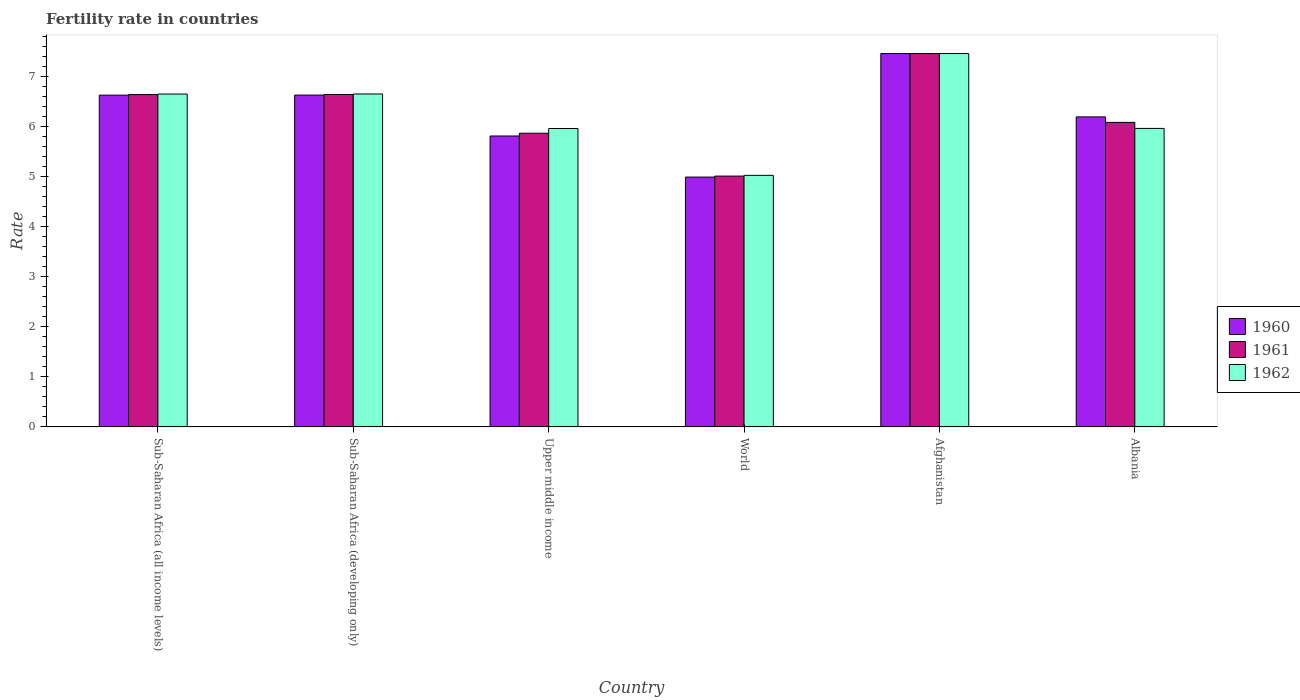Are the number of bars per tick equal to the number of legend labels?
Your response must be concise. Yes. Are the number of bars on each tick of the X-axis equal?
Offer a terse response. Yes. How many bars are there on the 4th tick from the left?
Make the answer very short. 3. What is the label of the 2nd group of bars from the left?
Give a very brief answer. Sub-Saharan Africa (developing only). In how many cases, is the number of bars for a given country not equal to the number of legend labels?
Your answer should be compact. 0. What is the fertility rate in 1961 in Upper middle income?
Provide a short and direct response. 5.86. Across all countries, what is the maximum fertility rate in 1962?
Give a very brief answer. 7.45. Across all countries, what is the minimum fertility rate in 1960?
Your answer should be compact. 4.99. In which country was the fertility rate in 1961 maximum?
Make the answer very short. Afghanistan. In which country was the fertility rate in 1960 minimum?
Your response must be concise. World. What is the total fertility rate in 1962 in the graph?
Offer a terse response. 37.66. What is the difference between the fertility rate in 1962 in Albania and that in Sub-Saharan Africa (developing only)?
Provide a short and direct response. -0.69. What is the difference between the fertility rate in 1961 in Afghanistan and the fertility rate in 1960 in Upper middle income?
Ensure brevity in your answer.  1.65. What is the average fertility rate in 1962 per country?
Offer a very short reply. 6.28. What is the difference between the fertility rate of/in 1962 and fertility rate of/in 1961 in Sub-Saharan Africa (all income levels)?
Your answer should be compact. 0.01. In how many countries, is the fertility rate in 1961 greater than 3.2?
Provide a short and direct response. 6. What is the ratio of the fertility rate in 1961 in Sub-Saharan Africa (all income levels) to that in Upper middle income?
Give a very brief answer. 1.13. Is the difference between the fertility rate in 1962 in Albania and Sub-Saharan Africa (developing only) greater than the difference between the fertility rate in 1961 in Albania and Sub-Saharan Africa (developing only)?
Your response must be concise. No. What is the difference between the highest and the second highest fertility rate in 1961?
Provide a succinct answer. -0. What is the difference between the highest and the lowest fertility rate in 1961?
Your answer should be very brief. 2.45. Is the sum of the fertility rate in 1962 in Sub-Saharan Africa (developing only) and Upper middle income greater than the maximum fertility rate in 1960 across all countries?
Give a very brief answer. Yes. What does the 1st bar from the left in Upper middle income represents?
Give a very brief answer. 1960. What does the 2nd bar from the right in Sub-Saharan Africa (all income levels) represents?
Provide a short and direct response. 1961. What is the difference between two consecutive major ticks on the Y-axis?
Provide a short and direct response. 1. Are the values on the major ticks of Y-axis written in scientific E-notation?
Provide a short and direct response. No. Does the graph contain any zero values?
Your response must be concise. No. Does the graph contain grids?
Keep it short and to the point. No. Where does the legend appear in the graph?
Keep it short and to the point. Center right. What is the title of the graph?
Ensure brevity in your answer.  Fertility rate in countries. What is the label or title of the Y-axis?
Your answer should be compact. Rate. What is the Rate in 1960 in Sub-Saharan Africa (all income levels)?
Offer a very short reply. 6.62. What is the Rate in 1961 in Sub-Saharan Africa (all income levels)?
Make the answer very short. 6.63. What is the Rate in 1962 in Sub-Saharan Africa (all income levels)?
Keep it short and to the point. 6.64. What is the Rate of 1960 in Sub-Saharan Africa (developing only)?
Your answer should be compact. 6.62. What is the Rate of 1961 in Sub-Saharan Africa (developing only)?
Provide a short and direct response. 6.63. What is the Rate of 1962 in Sub-Saharan Africa (developing only)?
Keep it short and to the point. 6.64. What is the Rate in 1960 in Upper middle income?
Ensure brevity in your answer.  5.8. What is the Rate in 1961 in Upper middle income?
Ensure brevity in your answer.  5.86. What is the Rate in 1962 in Upper middle income?
Ensure brevity in your answer.  5.95. What is the Rate of 1960 in World?
Give a very brief answer. 4.99. What is the Rate in 1961 in World?
Make the answer very short. 5. What is the Rate in 1962 in World?
Offer a terse response. 5.02. What is the Rate of 1960 in Afghanistan?
Your answer should be compact. 7.45. What is the Rate in 1961 in Afghanistan?
Keep it short and to the point. 7.45. What is the Rate in 1962 in Afghanistan?
Provide a short and direct response. 7.45. What is the Rate in 1960 in Albania?
Offer a terse response. 6.19. What is the Rate of 1961 in Albania?
Your answer should be compact. 6.08. What is the Rate of 1962 in Albania?
Provide a short and direct response. 5.96. Across all countries, what is the maximum Rate in 1960?
Provide a short and direct response. 7.45. Across all countries, what is the maximum Rate of 1961?
Your answer should be compact. 7.45. Across all countries, what is the maximum Rate of 1962?
Ensure brevity in your answer.  7.45. Across all countries, what is the minimum Rate in 1960?
Your answer should be compact. 4.99. Across all countries, what is the minimum Rate of 1961?
Offer a very short reply. 5. Across all countries, what is the minimum Rate of 1962?
Keep it short and to the point. 5.02. What is the total Rate in 1960 in the graph?
Provide a short and direct response. 37.67. What is the total Rate of 1961 in the graph?
Make the answer very short. 37.65. What is the total Rate of 1962 in the graph?
Provide a succinct answer. 37.66. What is the difference between the Rate of 1960 in Sub-Saharan Africa (all income levels) and that in Sub-Saharan Africa (developing only)?
Keep it short and to the point. -0. What is the difference between the Rate of 1961 in Sub-Saharan Africa (all income levels) and that in Sub-Saharan Africa (developing only)?
Your answer should be very brief. -0. What is the difference between the Rate of 1962 in Sub-Saharan Africa (all income levels) and that in Sub-Saharan Africa (developing only)?
Offer a very short reply. -0. What is the difference between the Rate in 1960 in Sub-Saharan Africa (all income levels) and that in Upper middle income?
Offer a terse response. 0.82. What is the difference between the Rate of 1961 in Sub-Saharan Africa (all income levels) and that in Upper middle income?
Make the answer very short. 0.77. What is the difference between the Rate in 1962 in Sub-Saharan Africa (all income levels) and that in Upper middle income?
Give a very brief answer. 0.69. What is the difference between the Rate of 1960 in Sub-Saharan Africa (all income levels) and that in World?
Make the answer very short. 1.64. What is the difference between the Rate of 1961 in Sub-Saharan Africa (all income levels) and that in World?
Keep it short and to the point. 1.63. What is the difference between the Rate in 1962 in Sub-Saharan Africa (all income levels) and that in World?
Ensure brevity in your answer.  1.62. What is the difference between the Rate in 1960 in Sub-Saharan Africa (all income levels) and that in Afghanistan?
Offer a terse response. -0.83. What is the difference between the Rate of 1961 in Sub-Saharan Africa (all income levels) and that in Afghanistan?
Your response must be concise. -0.82. What is the difference between the Rate of 1962 in Sub-Saharan Africa (all income levels) and that in Afghanistan?
Provide a succinct answer. -0.81. What is the difference between the Rate of 1960 in Sub-Saharan Africa (all income levels) and that in Albania?
Give a very brief answer. 0.43. What is the difference between the Rate in 1961 in Sub-Saharan Africa (all income levels) and that in Albania?
Offer a terse response. 0.56. What is the difference between the Rate in 1962 in Sub-Saharan Africa (all income levels) and that in Albania?
Keep it short and to the point. 0.69. What is the difference between the Rate of 1960 in Sub-Saharan Africa (developing only) and that in Upper middle income?
Give a very brief answer. 0.82. What is the difference between the Rate of 1961 in Sub-Saharan Africa (developing only) and that in Upper middle income?
Ensure brevity in your answer.  0.77. What is the difference between the Rate of 1962 in Sub-Saharan Africa (developing only) and that in Upper middle income?
Keep it short and to the point. 0.69. What is the difference between the Rate of 1960 in Sub-Saharan Africa (developing only) and that in World?
Provide a succinct answer. 1.64. What is the difference between the Rate in 1961 in Sub-Saharan Africa (developing only) and that in World?
Offer a very short reply. 1.63. What is the difference between the Rate in 1962 in Sub-Saharan Africa (developing only) and that in World?
Your answer should be very brief. 1.62. What is the difference between the Rate in 1960 in Sub-Saharan Africa (developing only) and that in Afghanistan?
Give a very brief answer. -0.83. What is the difference between the Rate in 1961 in Sub-Saharan Africa (developing only) and that in Afghanistan?
Ensure brevity in your answer.  -0.82. What is the difference between the Rate of 1962 in Sub-Saharan Africa (developing only) and that in Afghanistan?
Your answer should be very brief. -0.81. What is the difference between the Rate in 1960 in Sub-Saharan Africa (developing only) and that in Albania?
Make the answer very short. 0.44. What is the difference between the Rate in 1961 in Sub-Saharan Africa (developing only) and that in Albania?
Ensure brevity in your answer.  0.56. What is the difference between the Rate in 1962 in Sub-Saharan Africa (developing only) and that in Albania?
Your answer should be compact. 0.69. What is the difference between the Rate in 1960 in Upper middle income and that in World?
Keep it short and to the point. 0.82. What is the difference between the Rate in 1961 in Upper middle income and that in World?
Provide a succinct answer. 0.86. What is the difference between the Rate in 1962 in Upper middle income and that in World?
Keep it short and to the point. 0.93. What is the difference between the Rate of 1960 in Upper middle income and that in Afghanistan?
Provide a short and direct response. -1.65. What is the difference between the Rate in 1961 in Upper middle income and that in Afghanistan?
Provide a short and direct response. -1.59. What is the difference between the Rate in 1962 in Upper middle income and that in Afghanistan?
Your answer should be very brief. -1.5. What is the difference between the Rate in 1960 in Upper middle income and that in Albania?
Ensure brevity in your answer.  -0.38. What is the difference between the Rate in 1961 in Upper middle income and that in Albania?
Your response must be concise. -0.22. What is the difference between the Rate of 1962 in Upper middle income and that in Albania?
Your response must be concise. -0. What is the difference between the Rate of 1960 in World and that in Afghanistan?
Provide a succinct answer. -2.46. What is the difference between the Rate of 1961 in World and that in Afghanistan?
Make the answer very short. -2.45. What is the difference between the Rate in 1962 in World and that in Afghanistan?
Offer a very short reply. -2.43. What is the difference between the Rate of 1960 in World and that in Albania?
Provide a short and direct response. -1.2. What is the difference between the Rate of 1961 in World and that in Albania?
Give a very brief answer. -1.07. What is the difference between the Rate in 1962 in World and that in Albania?
Make the answer very short. -0.94. What is the difference between the Rate in 1960 in Afghanistan and that in Albania?
Your response must be concise. 1.26. What is the difference between the Rate in 1961 in Afghanistan and that in Albania?
Offer a very short reply. 1.37. What is the difference between the Rate of 1962 in Afghanistan and that in Albania?
Offer a very short reply. 1.49. What is the difference between the Rate of 1960 in Sub-Saharan Africa (all income levels) and the Rate of 1961 in Sub-Saharan Africa (developing only)?
Ensure brevity in your answer.  -0.01. What is the difference between the Rate in 1960 in Sub-Saharan Africa (all income levels) and the Rate in 1962 in Sub-Saharan Africa (developing only)?
Your answer should be compact. -0.02. What is the difference between the Rate in 1961 in Sub-Saharan Africa (all income levels) and the Rate in 1962 in Sub-Saharan Africa (developing only)?
Your response must be concise. -0.01. What is the difference between the Rate of 1960 in Sub-Saharan Africa (all income levels) and the Rate of 1961 in Upper middle income?
Your answer should be very brief. 0.76. What is the difference between the Rate in 1960 in Sub-Saharan Africa (all income levels) and the Rate in 1962 in Upper middle income?
Keep it short and to the point. 0.67. What is the difference between the Rate of 1961 in Sub-Saharan Africa (all income levels) and the Rate of 1962 in Upper middle income?
Keep it short and to the point. 0.68. What is the difference between the Rate in 1960 in Sub-Saharan Africa (all income levels) and the Rate in 1961 in World?
Ensure brevity in your answer.  1.62. What is the difference between the Rate in 1960 in Sub-Saharan Africa (all income levels) and the Rate in 1962 in World?
Provide a short and direct response. 1.6. What is the difference between the Rate of 1961 in Sub-Saharan Africa (all income levels) and the Rate of 1962 in World?
Make the answer very short. 1.61. What is the difference between the Rate of 1960 in Sub-Saharan Africa (all income levels) and the Rate of 1961 in Afghanistan?
Make the answer very short. -0.83. What is the difference between the Rate of 1960 in Sub-Saharan Africa (all income levels) and the Rate of 1962 in Afghanistan?
Keep it short and to the point. -0.83. What is the difference between the Rate in 1961 in Sub-Saharan Africa (all income levels) and the Rate in 1962 in Afghanistan?
Provide a succinct answer. -0.82. What is the difference between the Rate of 1960 in Sub-Saharan Africa (all income levels) and the Rate of 1961 in Albania?
Make the answer very short. 0.54. What is the difference between the Rate of 1960 in Sub-Saharan Africa (all income levels) and the Rate of 1962 in Albania?
Give a very brief answer. 0.66. What is the difference between the Rate of 1961 in Sub-Saharan Africa (all income levels) and the Rate of 1962 in Albania?
Your answer should be very brief. 0.68. What is the difference between the Rate in 1960 in Sub-Saharan Africa (developing only) and the Rate in 1961 in Upper middle income?
Your answer should be compact. 0.76. What is the difference between the Rate of 1960 in Sub-Saharan Africa (developing only) and the Rate of 1962 in Upper middle income?
Provide a short and direct response. 0.67. What is the difference between the Rate of 1961 in Sub-Saharan Africa (developing only) and the Rate of 1962 in Upper middle income?
Provide a succinct answer. 0.68. What is the difference between the Rate of 1960 in Sub-Saharan Africa (developing only) and the Rate of 1961 in World?
Your answer should be compact. 1.62. What is the difference between the Rate of 1960 in Sub-Saharan Africa (developing only) and the Rate of 1962 in World?
Make the answer very short. 1.6. What is the difference between the Rate of 1961 in Sub-Saharan Africa (developing only) and the Rate of 1962 in World?
Offer a terse response. 1.61. What is the difference between the Rate of 1960 in Sub-Saharan Africa (developing only) and the Rate of 1961 in Afghanistan?
Offer a terse response. -0.83. What is the difference between the Rate of 1960 in Sub-Saharan Africa (developing only) and the Rate of 1962 in Afghanistan?
Ensure brevity in your answer.  -0.83. What is the difference between the Rate of 1961 in Sub-Saharan Africa (developing only) and the Rate of 1962 in Afghanistan?
Your answer should be compact. -0.82. What is the difference between the Rate of 1960 in Sub-Saharan Africa (developing only) and the Rate of 1961 in Albania?
Your answer should be compact. 0.55. What is the difference between the Rate in 1960 in Sub-Saharan Africa (developing only) and the Rate in 1962 in Albania?
Ensure brevity in your answer.  0.67. What is the difference between the Rate in 1961 in Sub-Saharan Africa (developing only) and the Rate in 1962 in Albania?
Your answer should be very brief. 0.68. What is the difference between the Rate in 1960 in Upper middle income and the Rate in 1962 in World?
Make the answer very short. 0.79. What is the difference between the Rate in 1961 in Upper middle income and the Rate in 1962 in World?
Ensure brevity in your answer.  0.84. What is the difference between the Rate of 1960 in Upper middle income and the Rate of 1961 in Afghanistan?
Offer a very short reply. -1.65. What is the difference between the Rate in 1960 in Upper middle income and the Rate in 1962 in Afghanistan?
Provide a short and direct response. -1.65. What is the difference between the Rate of 1961 in Upper middle income and the Rate of 1962 in Afghanistan?
Your answer should be very brief. -1.59. What is the difference between the Rate in 1960 in Upper middle income and the Rate in 1961 in Albania?
Provide a short and direct response. -0.27. What is the difference between the Rate in 1960 in Upper middle income and the Rate in 1962 in Albania?
Ensure brevity in your answer.  -0.15. What is the difference between the Rate of 1961 in Upper middle income and the Rate of 1962 in Albania?
Ensure brevity in your answer.  -0.1. What is the difference between the Rate in 1960 in World and the Rate in 1961 in Afghanistan?
Ensure brevity in your answer.  -2.46. What is the difference between the Rate of 1960 in World and the Rate of 1962 in Afghanistan?
Provide a short and direct response. -2.46. What is the difference between the Rate of 1961 in World and the Rate of 1962 in Afghanistan?
Ensure brevity in your answer.  -2.45. What is the difference between the Rate of 1960 in World and the Rate of 1961 in Albania?
Provide a succinct answer. -1.09. What is the difference between the Rate of 1960 in World and the Rate of 1962 in Albania?
Your answer should be very brief. -0.97. What is the difference between the Rate in 1961 in World and the Rate in 1962 in Albania?
Give a very brief answer. -0.95. What is the difference between the Rate of 1960 in Afghanistan and the Rate of 1961 in Albania?
Your response must be concise. 1.37. What is the difference between the Rate of 1960 in Afghanistan and the Rate of 1962 in Albania?
Provide a short and direct response. 1.49. What is the difference between the Rate in 1961 in Afghanistan and the Rate in 1962 in Albania?
Your response must be concise. 1.49. What is the average Rate in 1960 per country?
Give a very brief answer. 6.28. What is the average Rate of 1961 per country?
Your response must be concise. 6.28. What is the average Rate of 1962 per country?
Provide a succinct answer. 6.28. What is the difference between the Rate in 1960 and Rate in 1961 in Sub-Saharan Africa (all income levels)?
Offer a terse response. -0.01. What is the difference between the Rate of 1960 and Rate of 1962 in Sub-Saharan Africa (all income levels)?
Give a very brief answer. -0.02. What is the difference between the Rate of 1961 and Rate of 1962 in Sub-Saharan Africa (all income levels)?
Your answer should be very brief. -0.01. What is the difference between the Rate of 1960 and Rate of 1961 in Sub-Saharan Africa (developing only)?
Your response must be concise. -0.01. What is the difference between the Rate in 1960 and Rate in 1962 in Sub-Saharan Africa (developing only)?
Make the answer very short. -0.02. What is the difference between the Rate of 1961 and Rate of 1962 in Sub-Saharan Africa (developing only)?
Offer a very short reply. -0.01. What is the difference between the Rate of 1960 and Rate of 1961 in Upper middle income?
Provide a short and direct response. -0.06. What is the difference between the Rate in 1960 and Rate in 1962 in Upper middle income?
Give a very brief answer. -0.15. What is the difference between the Rate in 1961 and Rate in 1962 in Upper middle income?
Your answer should be very brief. -0.09. What is the difference between the Rate in 1960 and Rate in 1961 in World?
Your answer should be very brief. -0.02. What is the difference between the Rate in 1960 and Rate in 1962 in World?
Your answer should be very brief. -0.03. What is the difference between the Rate of 1961 and Rate of 1962 in World?
Your answer should be very brief. -0.01. What is the difference between the Rate of 1961 and Rate of 1962 in Afghanistan?
Keep it short and to the point. 0. What is the difference between the Rate of 1960 and Rate of 1961 in Albania?
Keep it short and to the point. 0.11. What is the difference between the Rate in 1960 and Rate in 1962 in Albania?
Make the answer very short. 0.23. What is the difference between the Rate of 1961 and Rate of 1962 in Albania?
Ensure brevity in your answer.  0.12. What is the ratio of the Rate in 1960 in Sub-Saharan Africa (all income levels) to that in Sub-Saharan Africa (developing only)?
Provide a short and direct response. 1. What is the ratio of the Rate in 1962 in Sub-Saharan Africa (all income levels) to that in Sub-Saharan Africa (developing only)?
Offer a very short reply. 1. What is the ratio of the Rate of 1960 in Sub-Saharan Africa (all income levels) to that in Upper middle income?
Offer a terse response. 1.14. What is the ratio of the Rate in 1961 in Sub-Saharan Africa (all income levels) to that in Upper middle income?
Offer a very short reply. 1.13. What is the ratio of the Rate in 1962 in Sub-Saharan Africa (all income levels) to that in Upper middle income?
Provide a short and direct response. 1.12. What is the ratio of the Rate in 1960 in Sub-Saharan Africa (all income levels) to that in World?
Your response must be concise. 1.33. What is the ratio of the Rate in 1961 in Sub-Saharan Africa (all income levels) to that in World?
Provide a succinct answer. 1.33. What is the ratio of the Rate of 1962 in Sub-Saharan Africa (all income levels) to that in World?
Your answer should be very brief. 1.32. What is the ratio of the Rate in 1960 in Sub-Saharan Africa (all income levels) to that in Afghanistan?
Provide a succinct answer. 0.89. What is the ratio of the Rate of 1961 in Sub-Saharan Africa (all income levels) to that in Afghanistan?
Provide a short and direct response. 0.89. What is the ratio of the Rate of 1962 in Sub-Saharan Africa (all income levels) to that in Afghanistan?
Ensure brevity in your answer.  0.89. What is the ratio of the Rate in 1960 in Sub-Saharan Africa (all income levels) to that in Albania?
Your response must be concise. 1.07. What is the ratio of the Rate in 1961 in Sub-Saharan Africa (all income levels) to that in Albania?
Keep it short and to the point. 1.09. What is the ratio of the Rate in 1962 in Sub-Saharan Africa (all income levels) to that in Albania?
Offer a very short reply. 1.12. What is the ratio of the Rate of 1960 in Sub-Saharan Africa (developing only) to that in Upper middle income?
Make the answer very short. 1.14. What is the ratio of the Rate of 1961 in Sub-Saharan Africa (developing only) to that in Upper middle income?
Your response must be concise. 1.13. What is the ratio of the Rate of 1962 in Sub-Saharan Africa (developing only) to that in Upper middle income?
Offer a terse response. 1.12. What is the ratio of the Rate in 1960 in Sub-Saharan Africa (developing only) to that in World?
Your response must be concise. 1.33. What is the ratio of the Rate of 1961 in Sub-Saharan Africa (developing only) to that in World?
Provide a succinct answer. 1.33. What is the ratio of the Rate in 1962 in Sub-Saharan Africa (developing only) to that in World?
Offer a terse response. 1.32. What is the ratio of the Rate in 1960 in Sub-Saharan Africa (developing only) to that in Afghanistan?
Offer a terse response. 0.89. What is the ratio of the Rate in 1961 in Sub-Saharan Africa (developing only) to that in Afghanistan?
Keep it short and to the point. 0.89. What is the ratio of the Rate in 1962 in Sub-Saharan Africa (developing only) to that in Afghanistan?
Give a very brief answer. 0.89. What is the ratio of the Rate in 1960 in Sub-Saharan Africa (developing only) to that in Albania?
Offer a terse response. 1.07. What is the ratio of the Rate of 1961 in Sub-Saharan Africa (developing only) to that in Albania?
Ensure brevity in your answer.  1.09. What is the ratio of the Rate of 1962 in Sub-Saharan Africa (developing only) to that in Albania?
Provide a succinct answer. 1.12. What is the ratio of the Rate in 1960 in Upper middle income to that in World?
Make the answer very short. 1.16. What is the ratio of the Rate in 1961 in Upper middle income to that in World?
Provide a succinct answer. 1.17. What is the ratio of the Rate of 1962 in Upper middle income to that in World?
Ensure brevity in your answer.  1.19. What is the ratio of the Rate of 1960 in Upper middle income to that in Afghanistan?
Give a very brief answer. 0.78. What is the ratio of the Rate of 1961 in Upper middle income to that in Afghanistan?
Provide a short and direct response. 0.79. What is the ratio of the Rate of 1962 in Upper middle income to that in Afghanistan?
Your response must be concise. 0.8. What is the ratio of the Rate of 1960 in Upper middle income to that in Albania?
Your response must be concise. 0.94. What is the ratio of the Rate in 1961 in Upper middle income to that in Albania?
Ensure brevity in your answer.  0.96. What is the ratio of the Rate of 1960 in World to that in Afghanistan?
Your answer should be very brief. 0.67. What is the ratio of the Rate in 1961 in World to that in Afghanistan?
Offer a terse response. 0.67. What is the ratio of the Rate of 1962 in World to that in Afghanistan?
Make the answer very short. 0.67. What is the ratio of the Rate of 1960 in World to that in Albania?
Provide a short and direct response. 0.81. What is the ratio of the Rate of 1961 in World to that in Albania?
Offer a very short reply. 0.82. What is the ratio of the Rate of 1962 in World to that in Albania?
Make the answer very short. 0.84. What is the ratio of the Rate of 1960 in Afghanistan to that in Albania?
Give a very brief answer. 1.2. What is the ratio of the Rate of 1961 in Afghanistan to that in Albania?
Offer a very short reply. 1.23. What is the ratio of the Rate in 1962 in Afghanistan to that in Albania?
Your response must be concise. 1.25. What is the difference between the highest and the second highest Rate of 1960?
Offer a very short reply. 0.83. What is the difference between the highest and the second highest Rate of 1961?
Give a very brief answer. 0.82. What is the difference between the highest and the second highest Rate in 1962?
Offer a very short reply. 0.81. What is the difference between the highest and the lowest Rate in 1960?
Offer a terse response. 2.46. What is the difference between the highest and the lowest Rate of 1961?
Offer a terse response. 2.45. What is the difference between the highest and the lowest Rate in 1962?
Your answer should be very brief. 2.43. 